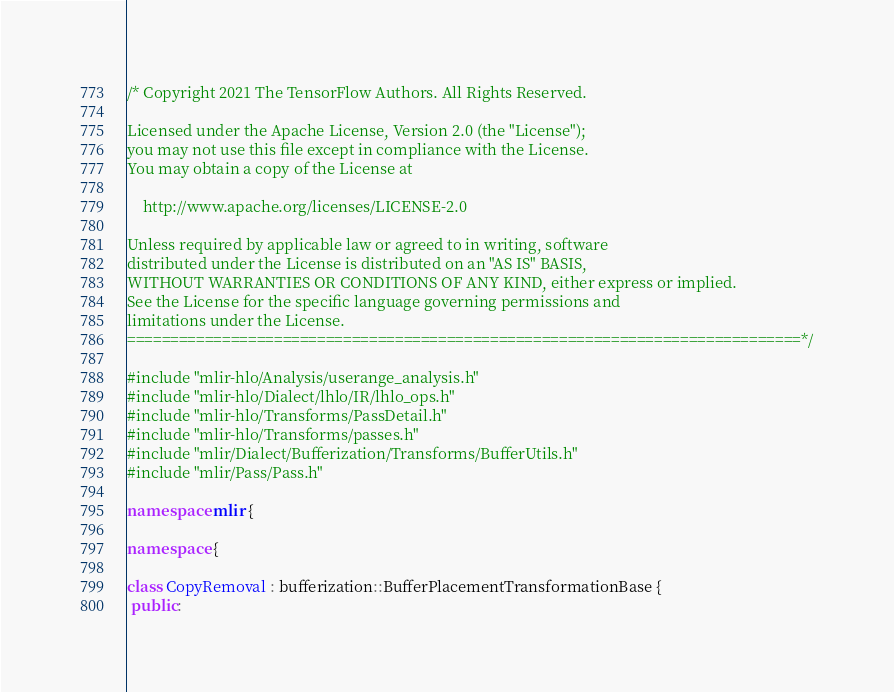<code> <loc_0><loc_0><loc_500><loc_500><_C++_>/* Copyright 2021 The TensorFlow Authors. All Rights Reserved.

Licensed under the Apache License, Version 2.0 (the "License");
you may not use this file except in compliance with the License.
You may obtain a copy of the License at

    http://www.apache.org/licenses/LICENSE-2.0

Unless required by applicable law or agreed to in writing, software
distributed under the License is distributed on an "AS IS" BASIS,
WITHOUT WARRANTIES OR CONDITIONS OF ANY KIND, either express or implied.
See the License for the specific language governing permissions and
limitations under the License.
==============================================================================*/

#include "mlir-hlo/Analysis/userange_analysis.h"
#include "mlir-hlo/Dialect/lhlo/IR/lhlo_ops.h"
#include "mlir-hlo/Transforms/PassDetail.h"
#include "mlir-hlo/Transforms/passes.h"
#include "mlir/Dialect/Bufferization/Transforms/BufferUtils.h"
#include "mlir/Pass/Pass.h"

namespace mlir {

namespace {

class CopyRemoval : bufferization::BufferPlacementTransformationBase {
 public:</code> 